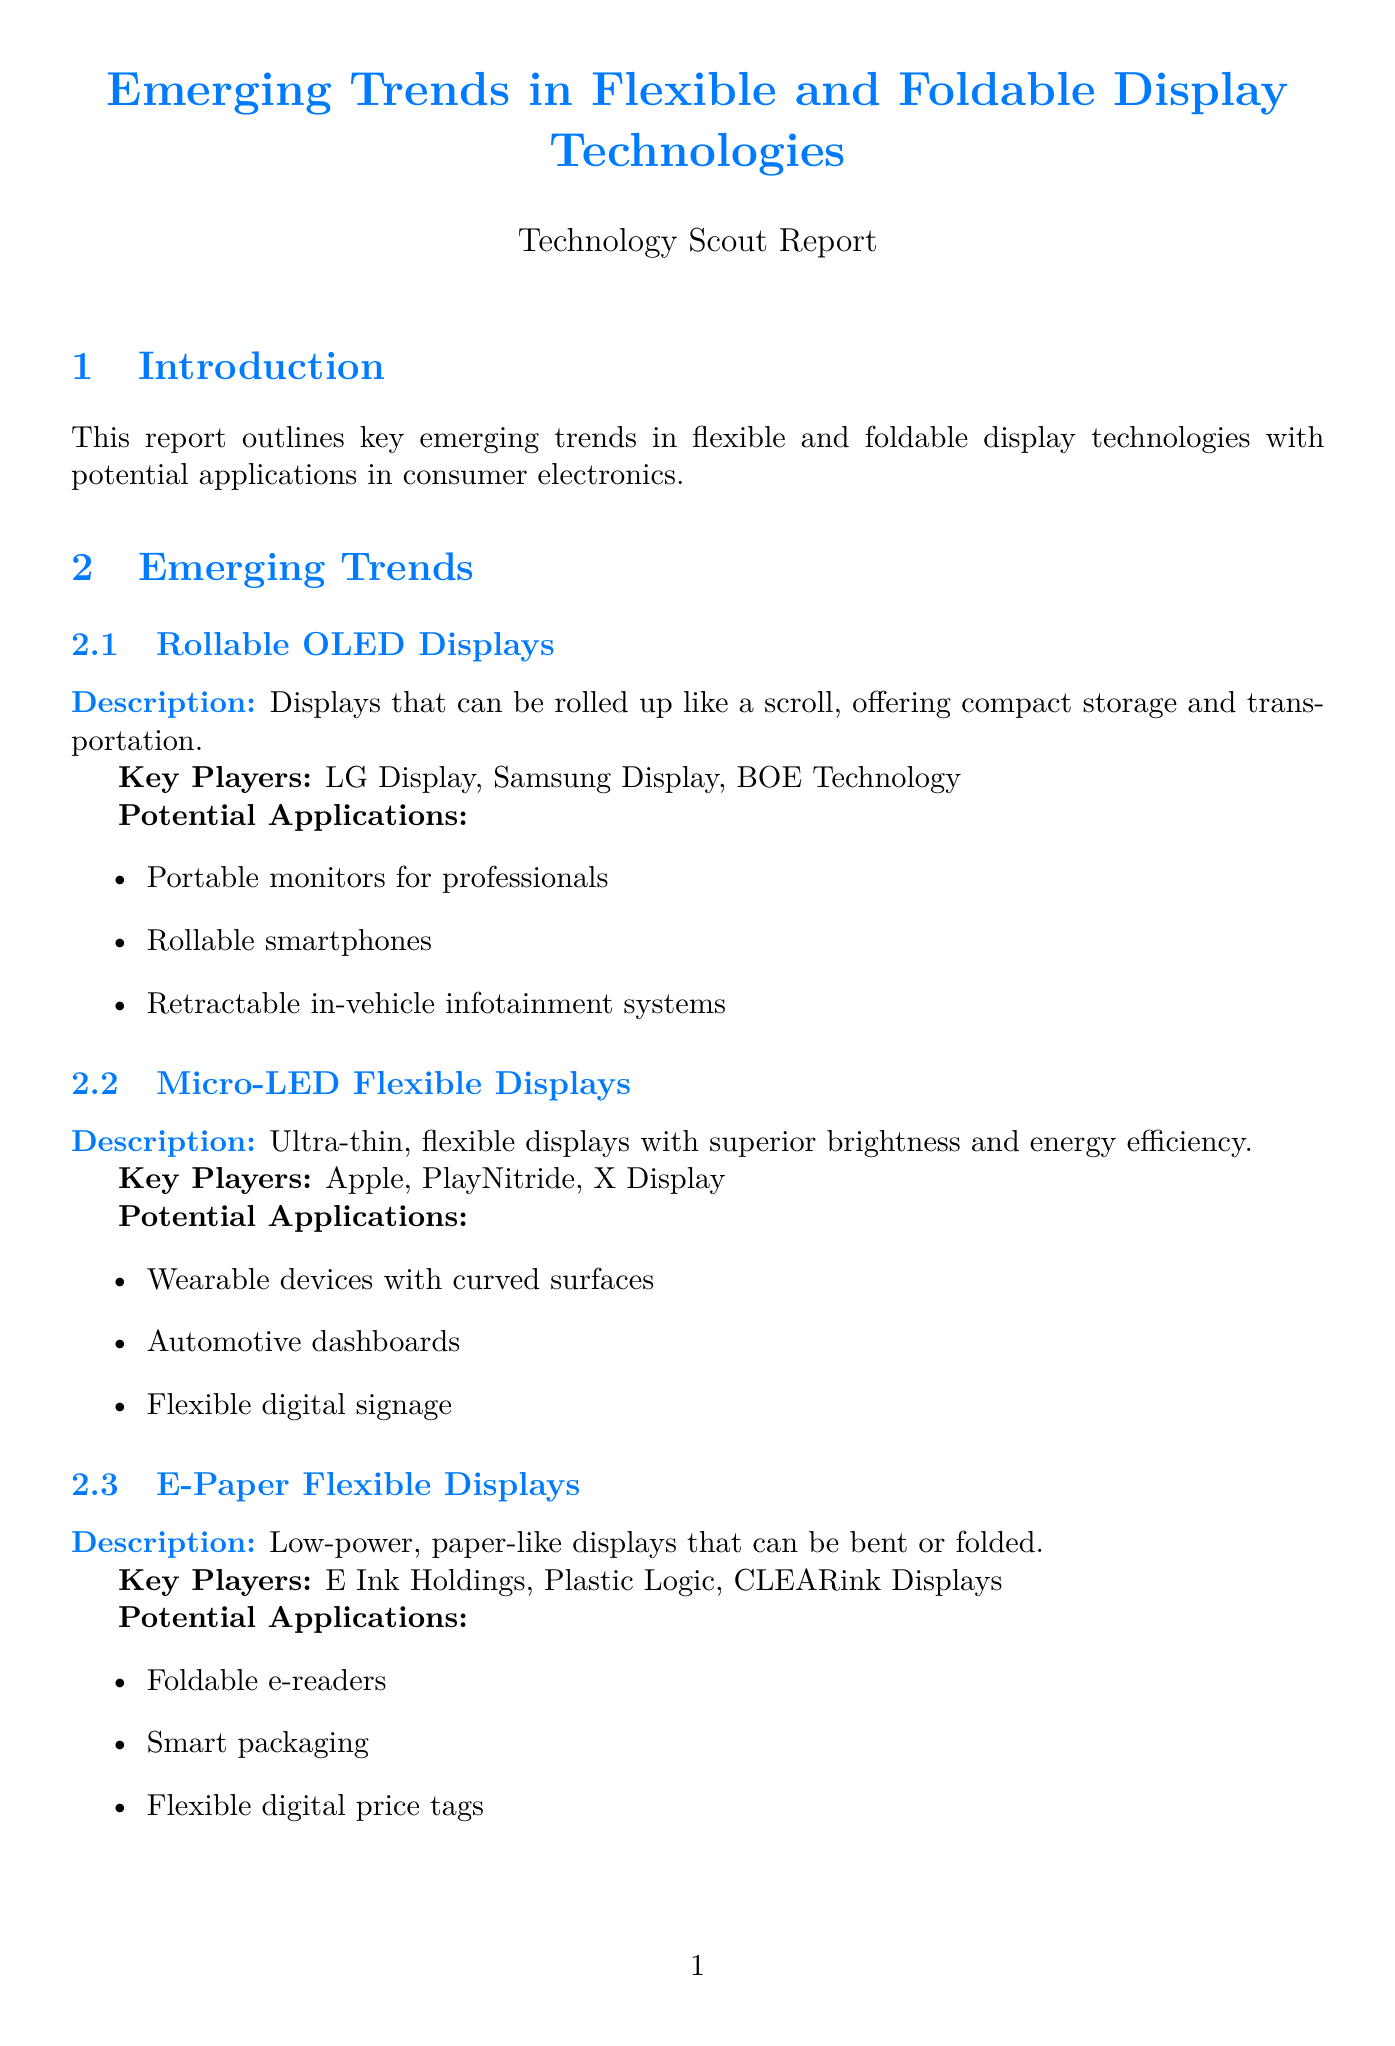What are the names of the key players in Rollable OLED Displays? The document lists LG Display, Samsung Display, and BOE Technology as the key players.
Answer: LG Display, Samsung Display, BOE Technology What is the market size projected for 2027? According to the market analysis section, the projected market size for 2027 is provided.
Answer: $28.7 billion What are two potential applications of Micro-LED Flexible Displays? The document specifies potential applications for Micro-LED Flexible Displays, including various consumer electronics uses.
Answer: Wearable devices with curved surfaces, Automotive dashboards Who is affiliated with the Flexible Electronics and Display Center? The document states that the Arizona State University is the affiliation of the Flexible Electronics and Display Center.
Answer: Arizona State University What is a challenge mentioned in the market analysis? The document outlines several challenges in the market analysis section, which can be retrieved from the list provided.
Answer: High manufacturing costs What are the focus areas of the Center for Flexible Electronics? This question requires retrieval of information related to the focus areas of the specified research institution.
Answer: Stretchable electronics, Printed electronics, Flexible sensors and actuators What product category includes the Nubia Alpha? The consumer electronics applications section categorizes products, including the Nubia Alpha under a specific category.
Answer: Wearables What future concept is mentioned for laptops? The document discusses future concepts for laptops, requiring reference to that section for the answer.
Answer: Laptops with rollable screens for expanded workspace What material is highlighted for ultrathin glass manufacturing benefits? This question pertains to the benefits outlined for ultrathin glass manufacturing, pulling directly from the document's details.
Answer: Improved durability compared to plastic substrates 